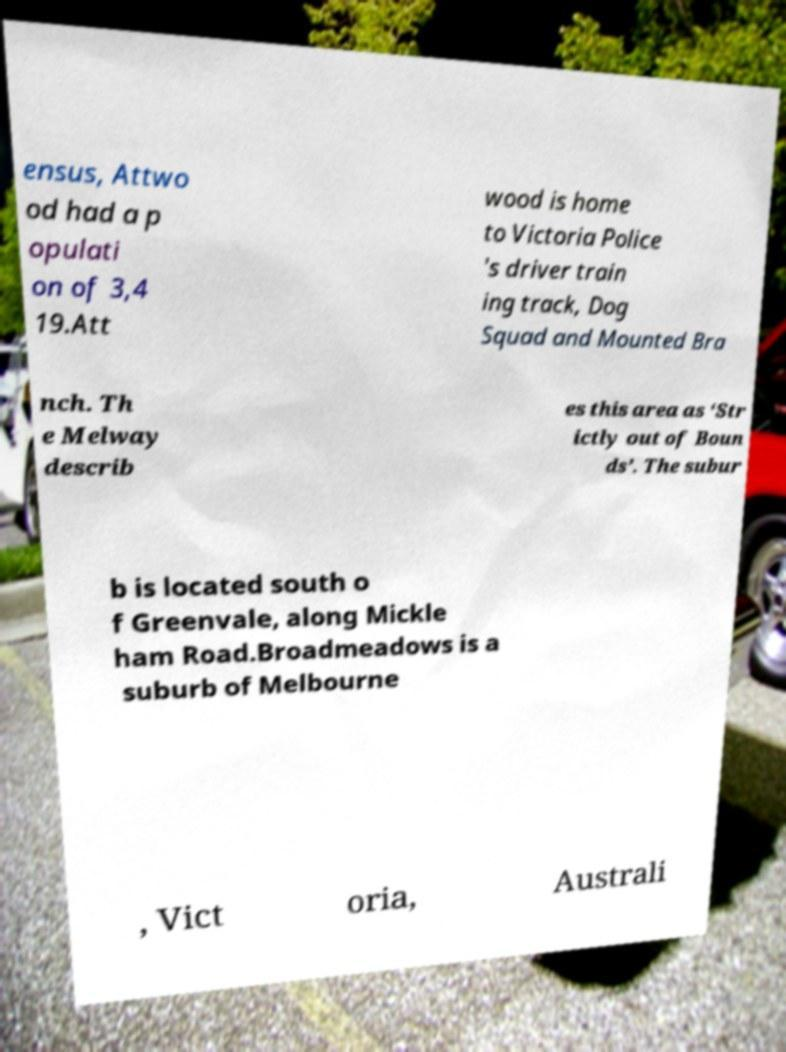Can you read and provide the text displayed in the image?This photo seems to have some interesting text. Can you extract and type it out for me? ensus, Attwo od had a p opulati on of 3,4 19.Att wood is home to Victoria Police 's driver train ing track, Dog Squad and Mounted Bra nch. Th e Melway describ es this area as ‘Str ictly out of Boun ds’. The subur b is located south o f Greenvale, along Mickle ham Road.Broadmeadows is a suburb of Melbourne , Vict oria, Australi 